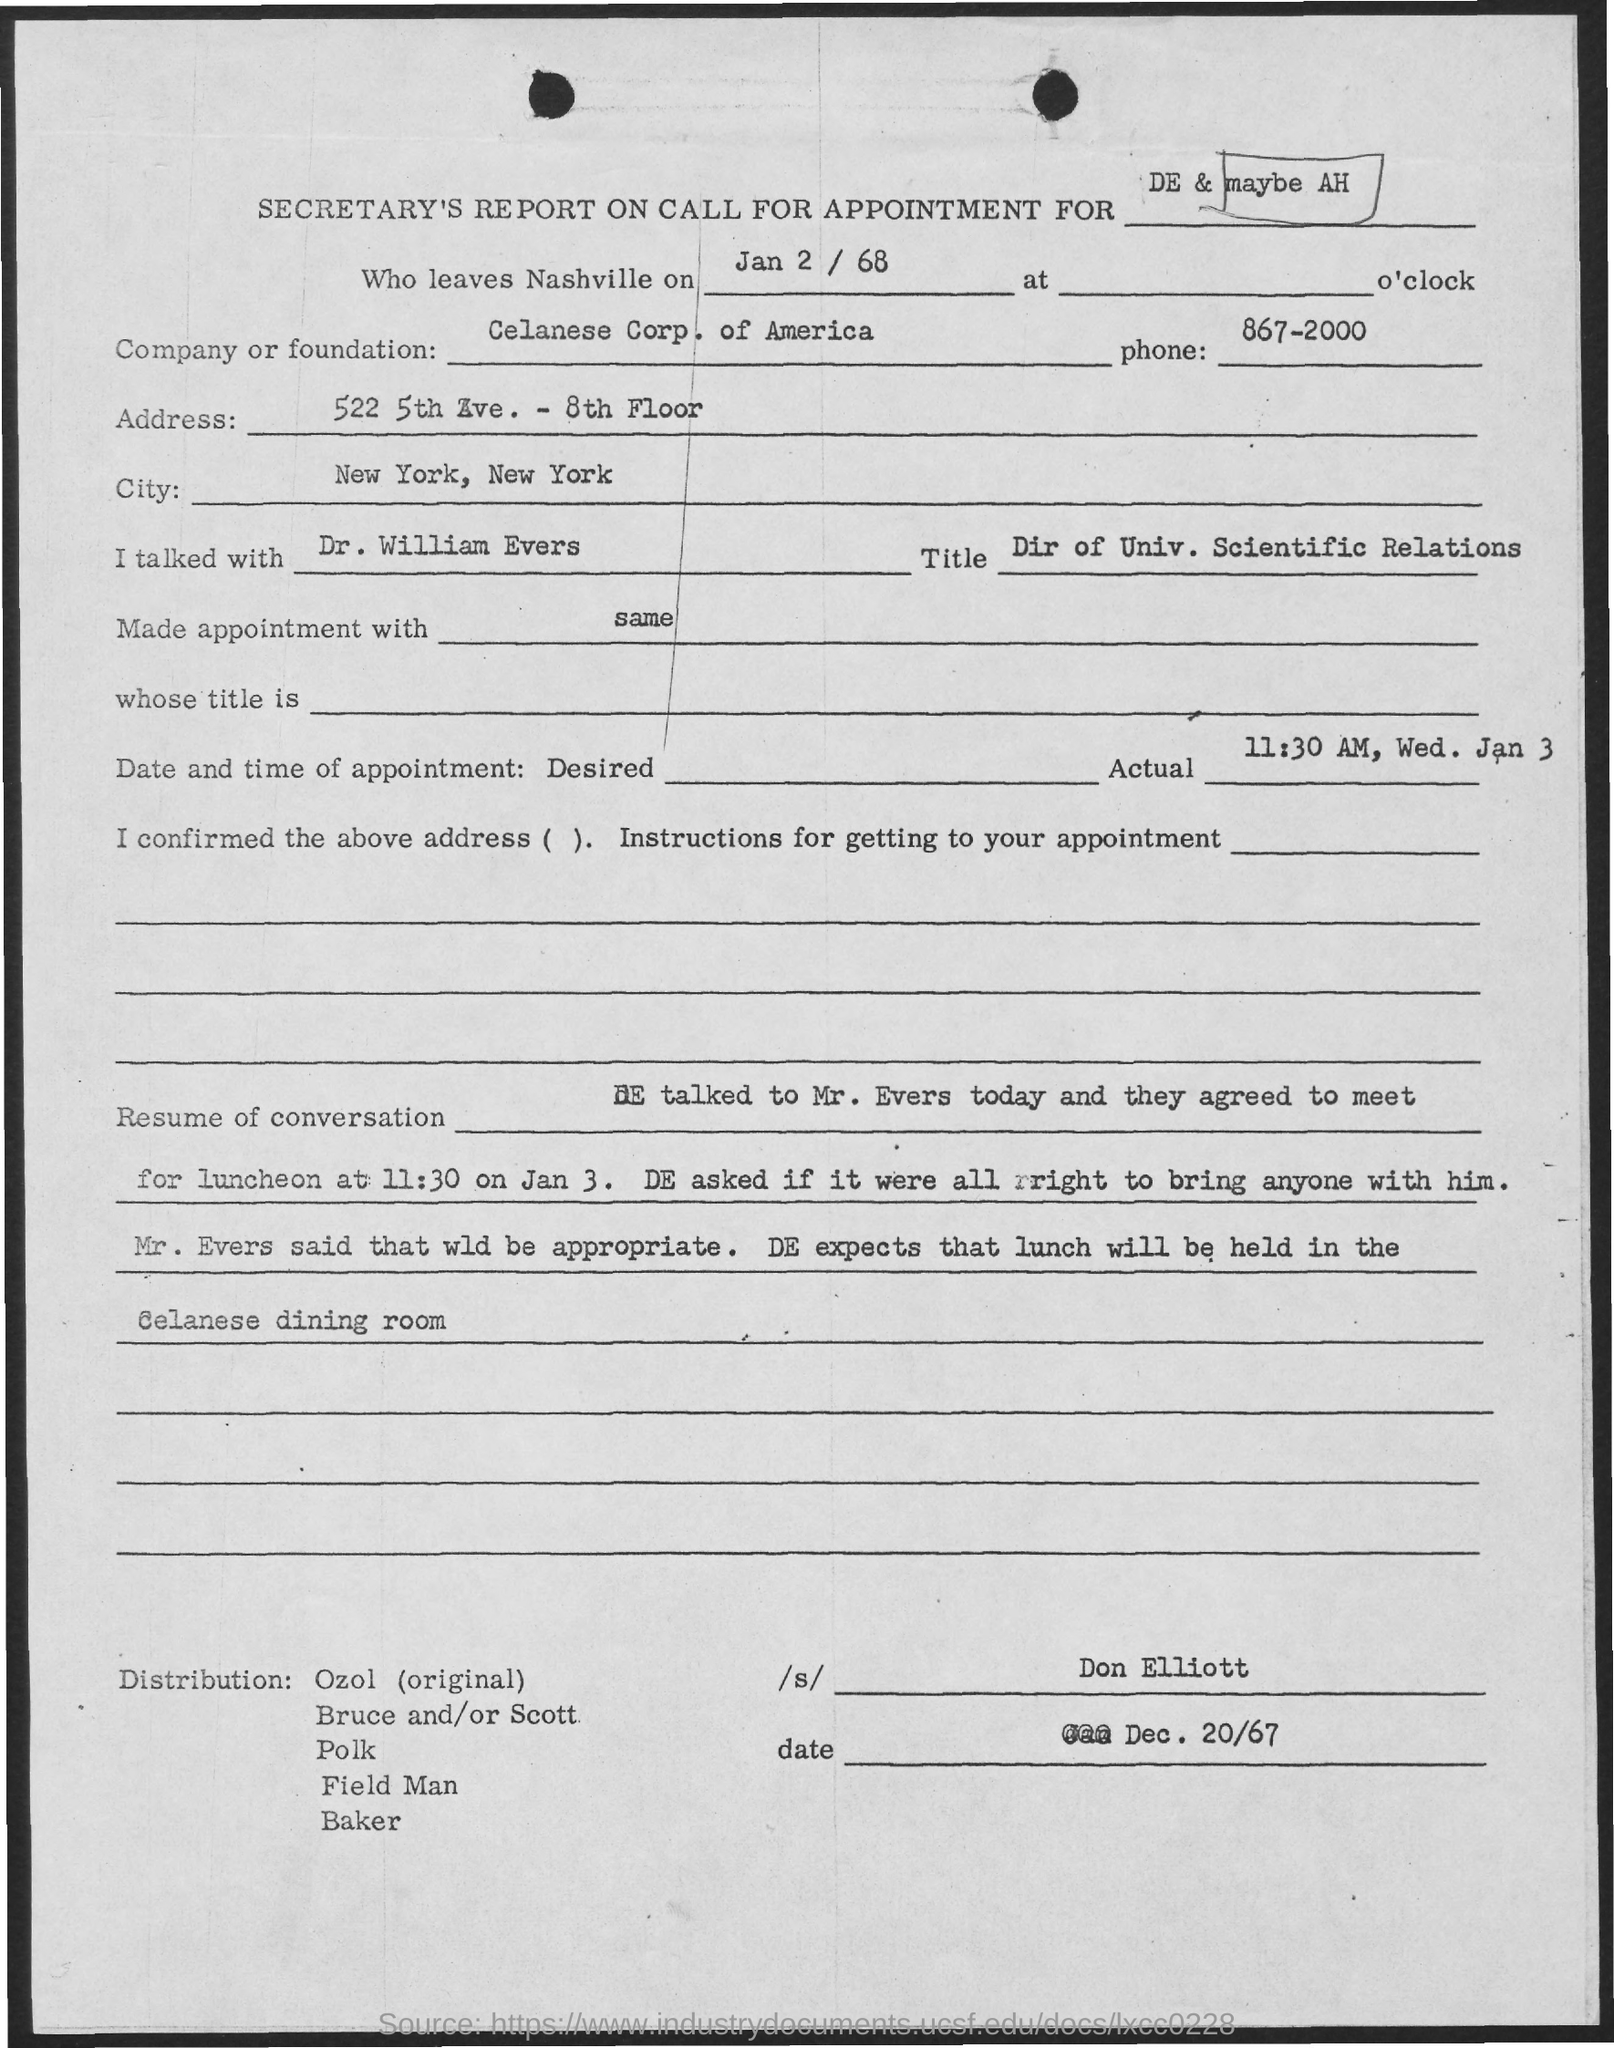Point out several critical features in this image. 522 5th Ave. - 8th Floor is the address. The city is New York, New York. On January 2nd, 1968, they left Nashville. The phrase 'What is the Phone? 867-2000...' is a telephone number with a sequence of digits designed to simulate a telephone keypad and prompt the listener to deduce the telephone number being dialed. The appointment is scheduled for 11:30 AM on Wednesday, January 3rd. 